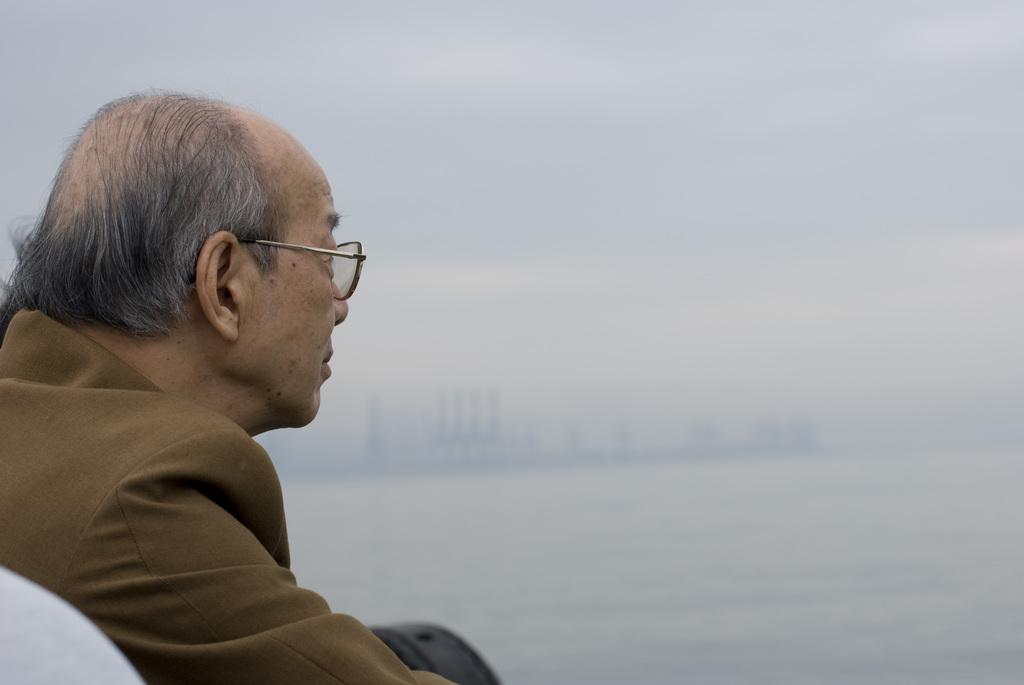Who is the main subject in the image? There is an old man in the image. What accessory is the old man wearing? The old man is wearing glasses. What color is the object in the image? There is a black color object in the image. What can be seen in the background of the image? The background of the image includes the sky. What color is present at the bottom left side of the image? The bottom left side of the image has a white color. How many stamps does the old man have in his possession in the image? There is no indication of stamps in the image; the old man is simply wearing glasses and standing in front of a background with the sky. 